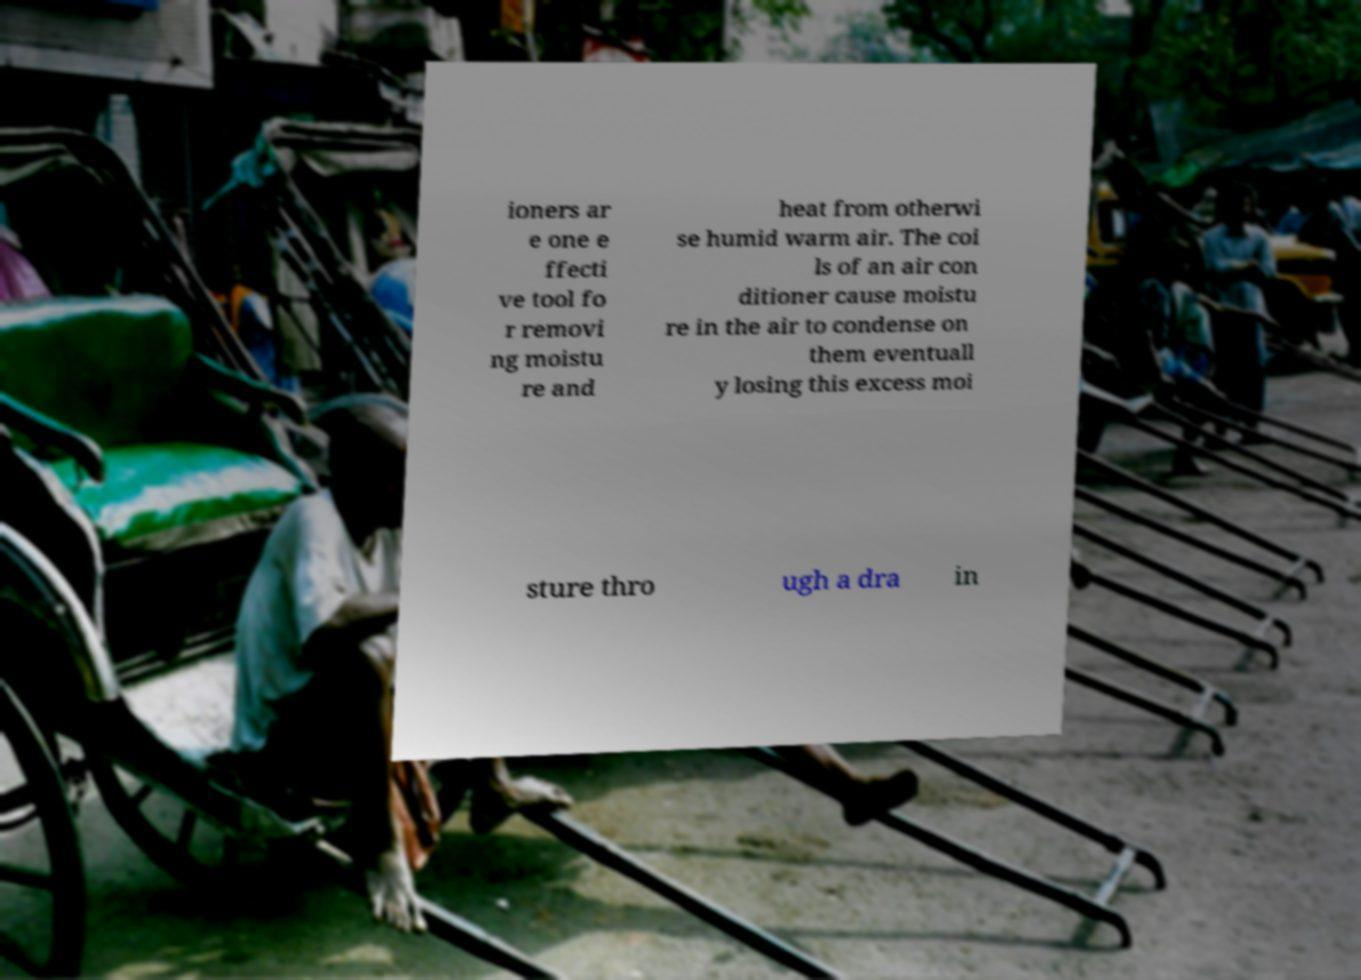Could you extract and type out the text from this image? ioners ar e one e ffecti ve tool fo r removi ng moistu re and heat from otherwi se humid warm air. The coi ls of an air con ditioner cause moistu re in the air to condense on them eventuall y losing this excess moi sture thro ugh a dra in 